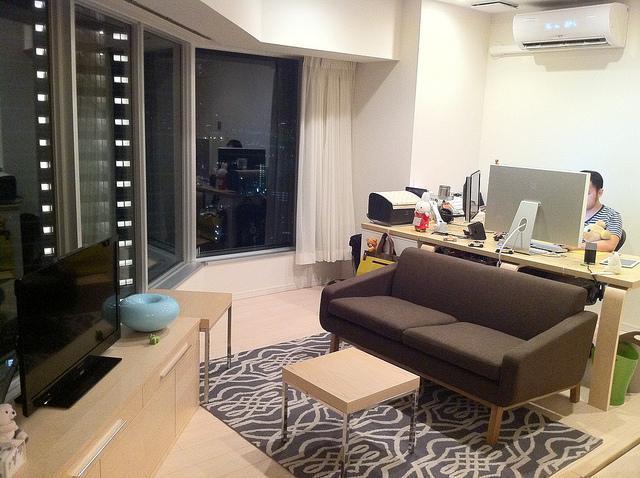How many tvs can be seen?
Give a very brief answer. 2. How many black railroad cars are at the train station?
Give a very brief answer. 0. 